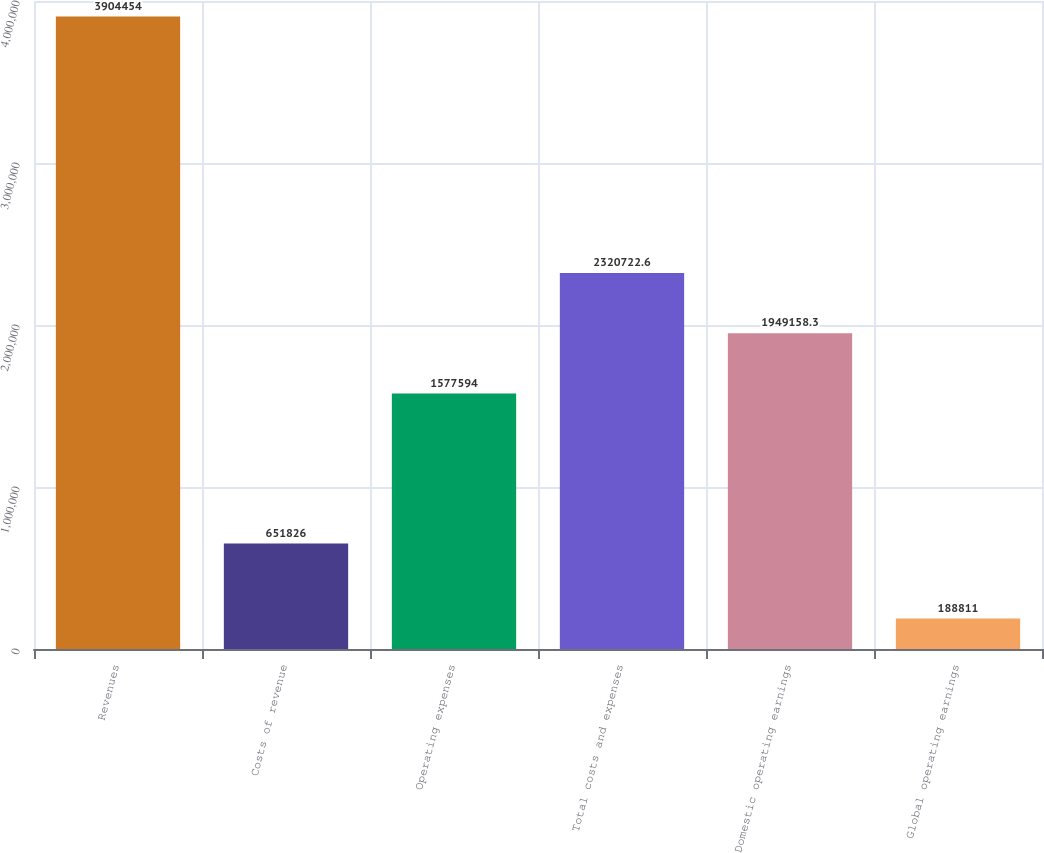<chart> <loc_0><loc_0><loc_500><loc_500><bar_chart><fcel>Revenues<fcel>Costs of revenue<fcel>Operating expenses<fcel>Total costs and expenses<fcel>Domestic operating earnings<fcel>Global operating earnings<nl><fcel>3.90445e+06<fcel>651826<fcel>1.57759e+06<fcel>2.32072e+06<fcel>1.94916e+06<fcel>188811<nl></chart> 